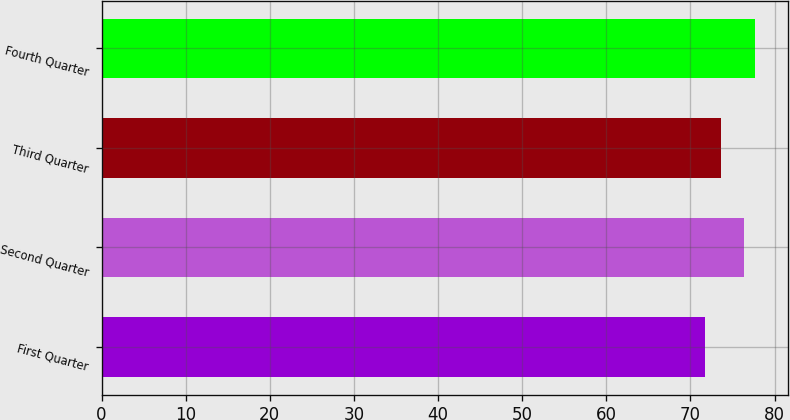Convert chart. <chart><loc_0><loc_0><loc_500><loc_500><bar_chart><fcel>First Quarter<fcel>Second Quarter<fcel>Third Quarter<fcel>Fourth Quarter<nl><fcel>71.74<fcel>76.4<fcel>73.67<fcel>77.66<nl></chart> 